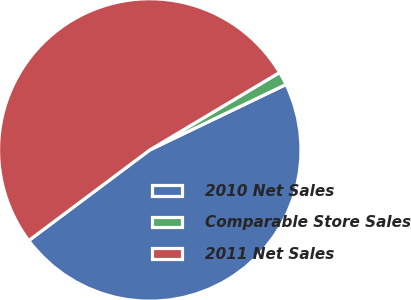<chart> <loc_0><loc_0><loc_500><loc_500><pie_chart><fcel>2010 Net Sales<fcel>Comparable Store Sales<fcel>2011 Net Sales<nl><fcel>46.91%<fcel>1.43%<fcel>51.66%<nl></chart> 